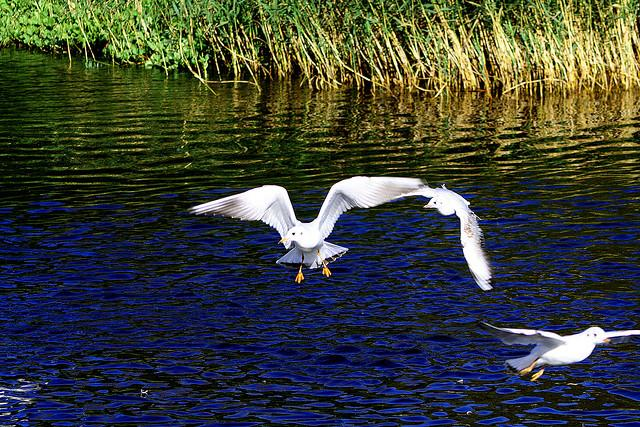What is in the air? seagulls 